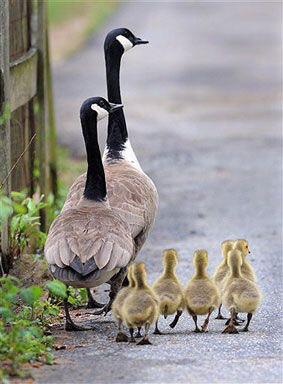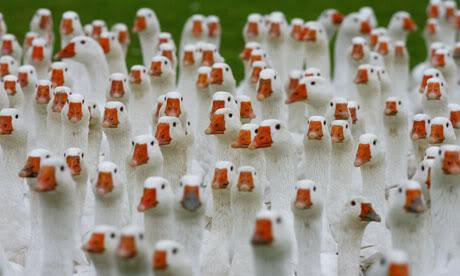The first image is the image on the left, the second image is the image on the right. Considering the images on both sides, is "At least one of the birds is in a watery area." valid? Answer yes or no. No. The first image is the image on the left, the second image is the image on the right. Given the left and right images, does the statement "There are two adult black and brown geese visible" hold true? Answer yes or no. Yes. 